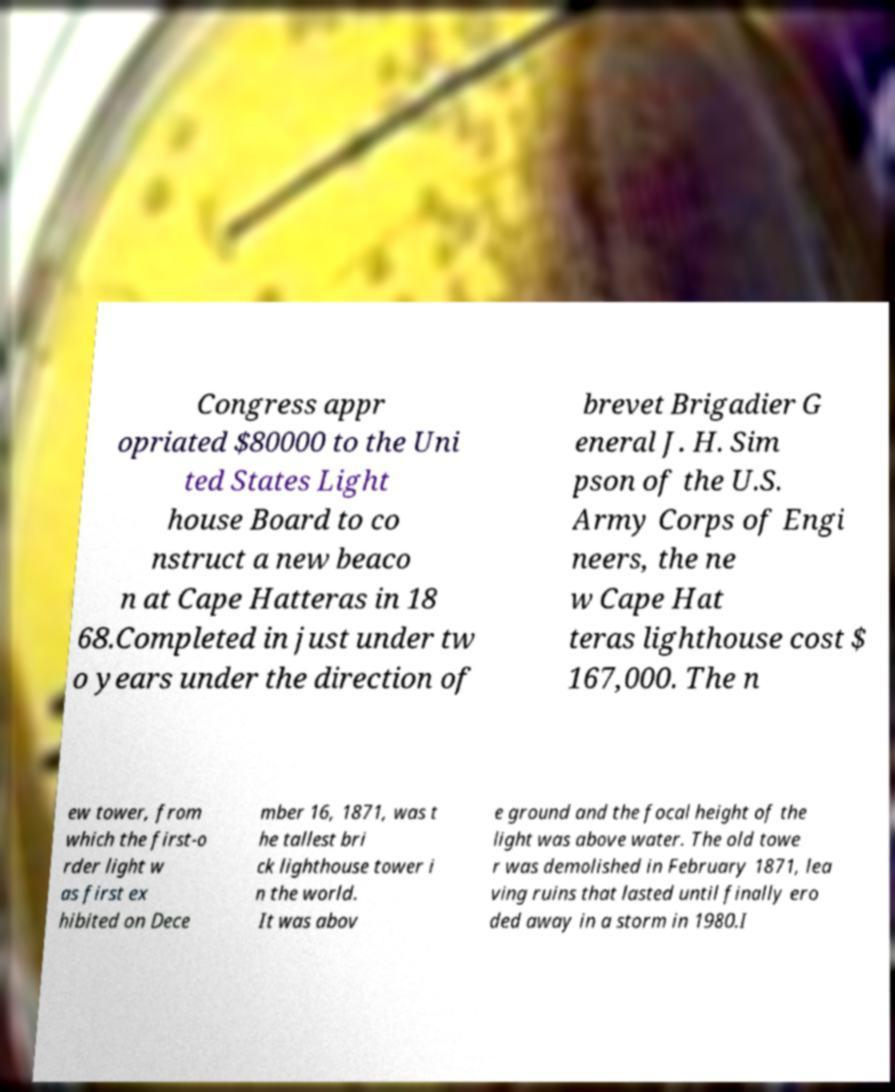What messages or text are displayed in this image? I need them in a readable, typed format. Congress appr opriated $80000 to the Uni ted States Light house Board to co nstruct a new beaco n at Cape Hatteras in 18 68.Completed in just under tw o years under the direction of brevet Brigadier G eneral J. H. Sim pson of the U.S. Army Corps of Engi neers, the ne w Cape Hat teras lighthouse cost $ 167,000. The n ew tower, from which the first-o rder light w as first ex hibited on Dece mber 16, 1871, was t he tallest bri ck lighthouse tower i n the world. It was abov e ground and the focal height of the light was above water. The old towe r was demolished in February 1871, lea ving ruins that lasted until finally ero ded away in a storm in 1980.I 